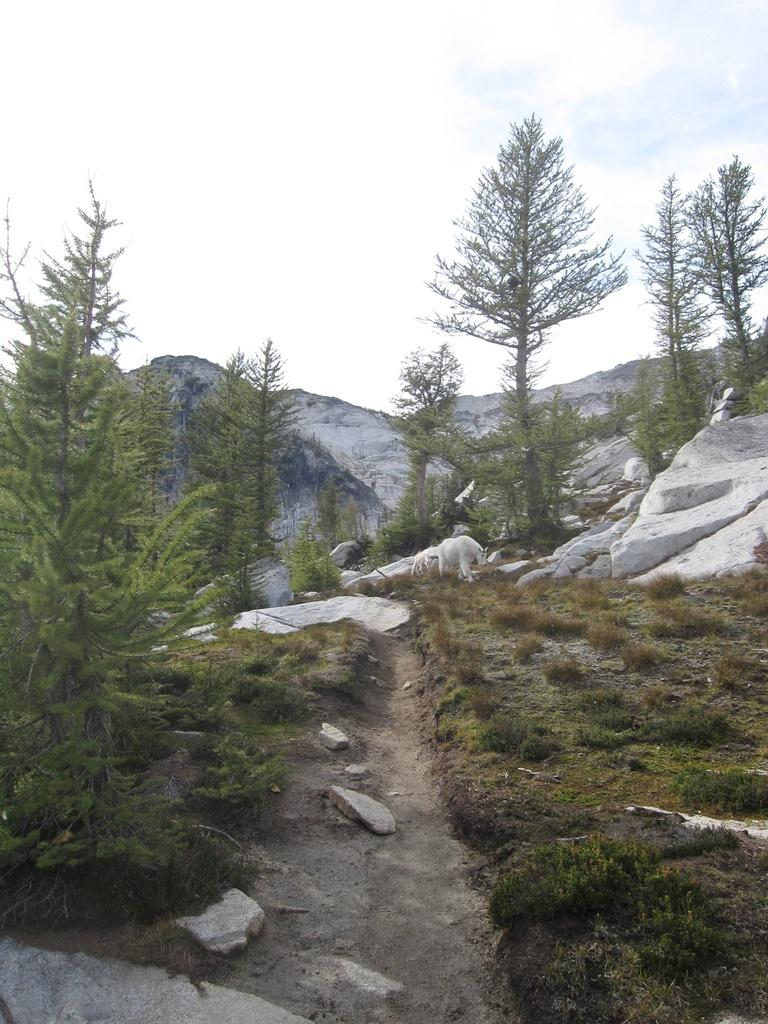How many animals are present in the image? There are two animals in the image. What is the location of the animals in the image? The animals are on the surface of the grass. What can be seen in the background of the image? There are trees, mountains, and the sky visible in the background of the image. Can you tell me how the animals are trying to join the hydrant in the image? There is no hydrant present in the image, so the animals are not trying to join anything of that nature. 